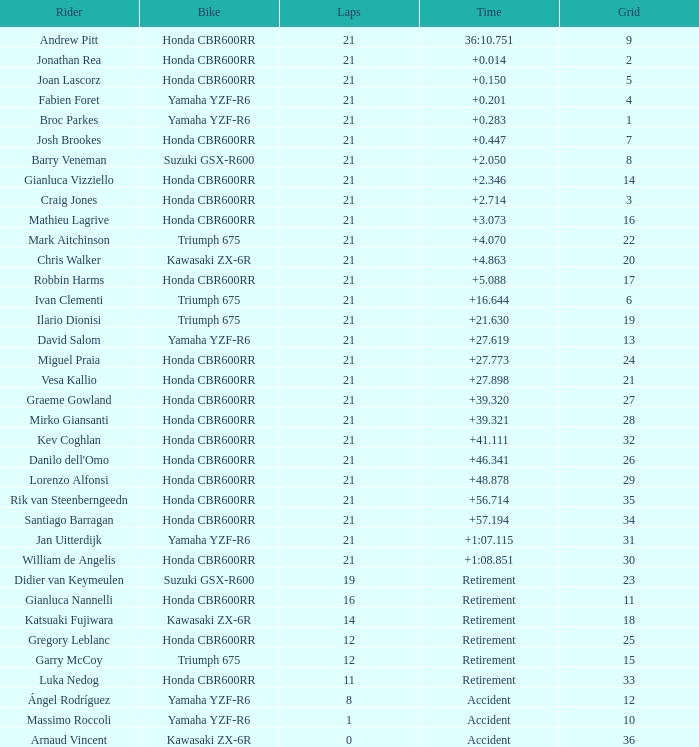What is the total of laps run by the driver with a grid under 17 and a time of +5.088? None. 